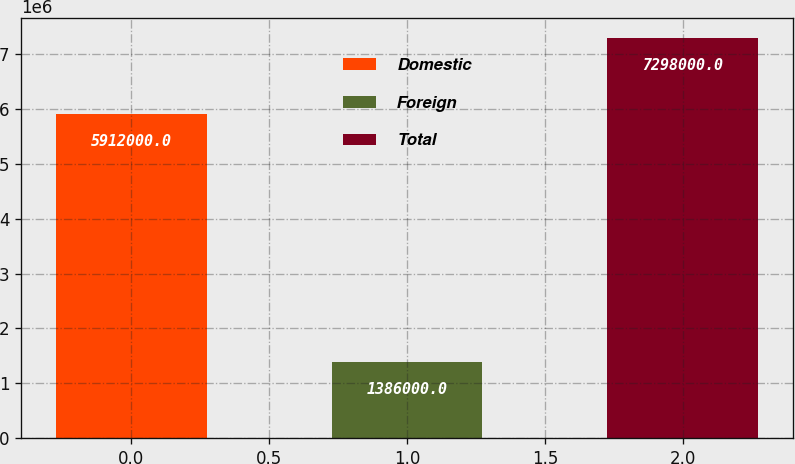<chart> <loc_0><loc_0><loc_500><loc_500><bar_chart><fcel>Domestic<fcel>Foreign<fcel>Total<nl><fcel>5.912e+06<fcel>1.386e+06<fcel>7.298e+06<nl></chart> 